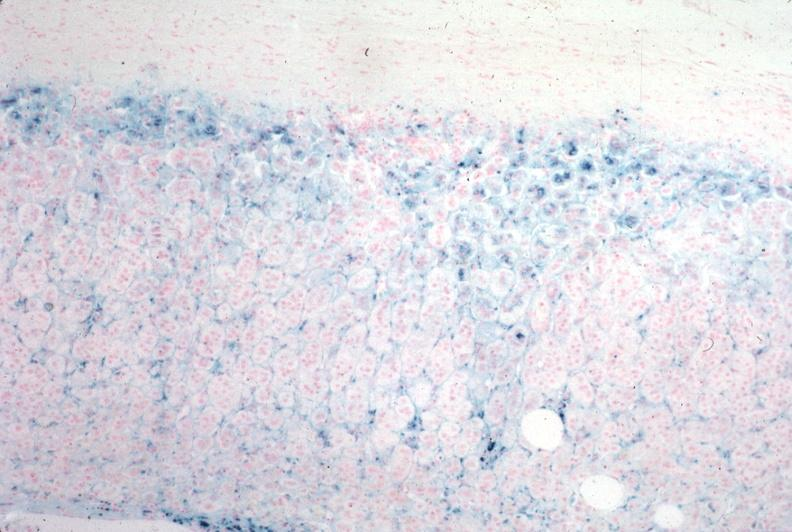what is present?
Answer the question using a single word or phrase. Hemochromatosis 